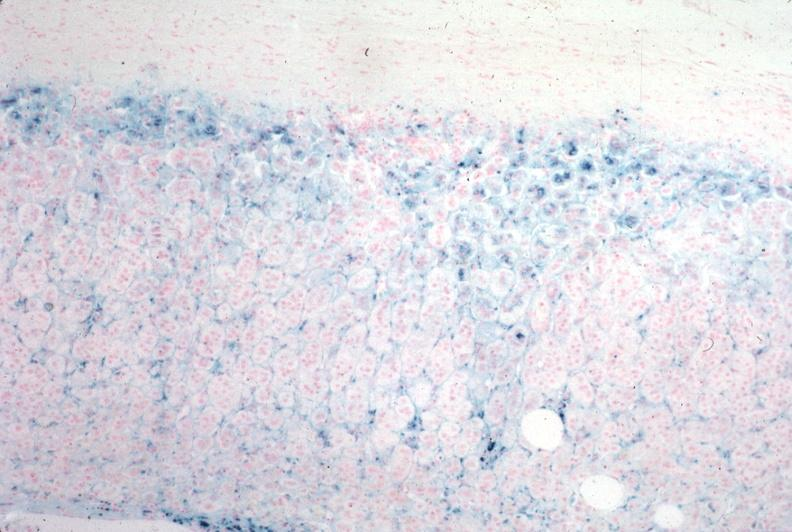what is present?
Answer the question using a single word or phrase. Hemochromatosis 